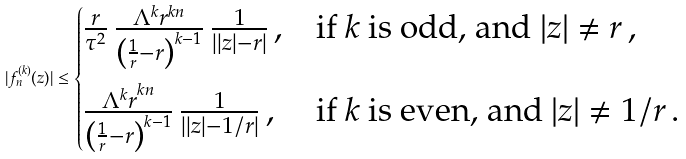<formula> <loc_0><loc_0><loc_500><loc_500>| f _ { n } ^ { ( k ) } ( z ) | \leq \begin{cases} \frac { r } { \tau ^ { 2 } } \, \frac { \Lambda ^ { k } r ^ { k n } } { \left ( \frac { 1 } { r } - r \right ) ^ { k - 1 } } \, \frac { 1 } { \left | | z | - r \right | } \, , & \text {if $k$ is odd, and } | z | \neq r \, , \\ \frac { \Lambda ^ { k } r ^ { k n \strut } } { \left ( \frac { 1 } { r } - r \right ) ^ { k - 1 } } \, \frac { 1 } { \left | | z | - 1 / r \right | } \, , & \text {if $k$ is even, and } | z | \neq 1 / r \, . \end{cases}</formula> 